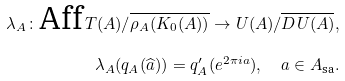<formula> <loc_0><loc_0><loc_500><loc_500>\lambda _ { A } \colon \text {Aff} \, T ( A ) / \overline { \rho _ { A } ( K _ { 0 } ( A ) ) } \to U ( A ) / \overline { D U ( A ) } , \\ \lambda _ { A } ( q _ { A } ( \widehat { a } ) ) = q _ { A } ^ { \prime } ( e ^ { 2 \pi i a } ) , \quad a \in A _ { \text {sa} } .</formula> 